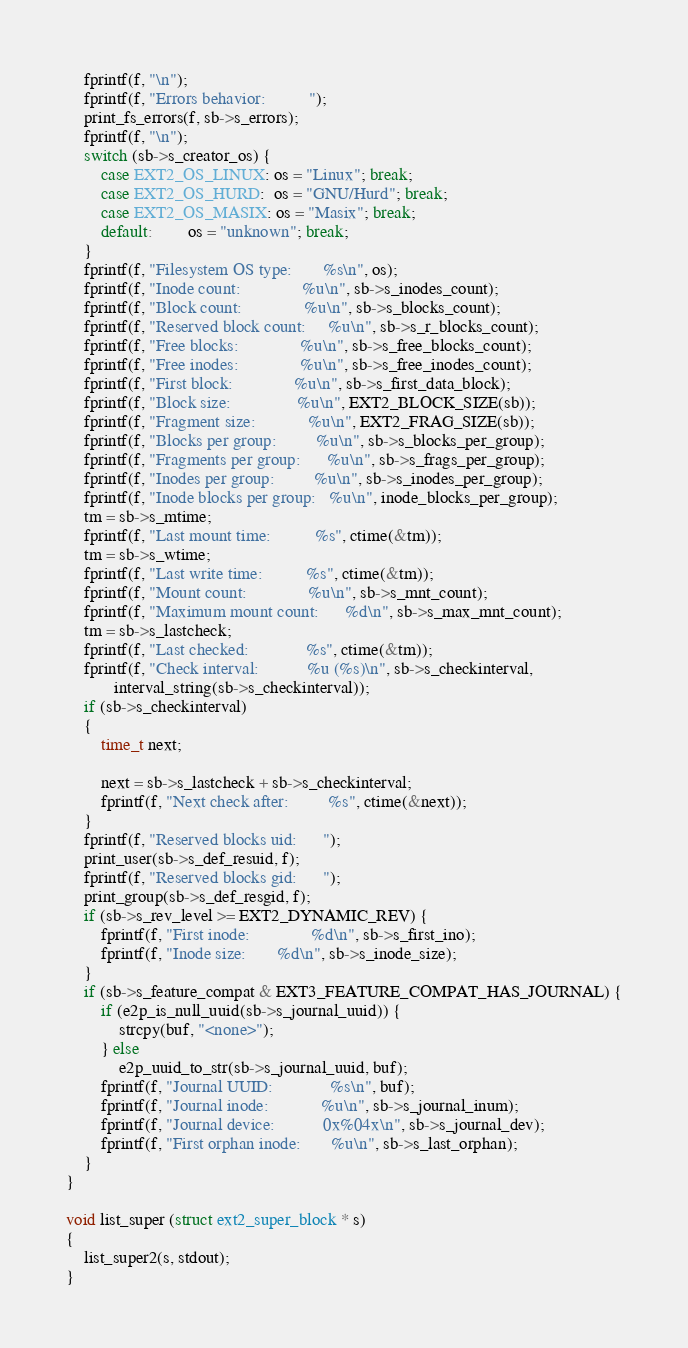<code> <loc_0><loc_0><loc_500><loc_500><_C_>	fprintf(f, "\n");
	fprintf(f, "Errors behavior:          ");
	print_fs_errors(f, sb->s_errors);
	fprintf(f, "\n");
	switch (sb->s_creator_os) {
	    case EXT2_OS_LINUX: os = "Linux"; break;
	    case EXT2_OS_HURD:  os = "GNU/Hurd"; break;
	    case EXT2_OS_MASIX: os = "Masix"; break;
	    default:		os = "unknown"; break;
	}
	fprintf(f, "Filesystem OS type:       %s\n", os);
	fprintf(f, "Inode count:              %u\n", sb->s_inodes_count);
	fprintf(f, "Block count:              %u\n", sb->s_blocks_count);
	fprintf(f, "Reserved block count:     %u\n", sb->s_r_blocks_count);
	fprintf(f, "Free blocks:              %u\n", sb->s_free_blocks_count);
	fprintf(f, "Free inodes:              %u\n", sb->s_free_inodes_count);
	fprintf(f, "First block:              %u\n", sb->s_first_data_block);
	fprintf(f, "Block size:               %u\n", EXT2_BLOCK_SIZE(sb));
	fprintf(f, "Fragment size:            %u\n", EXT2_FRAG_SIZE(sb));
	fprintf(f, "Blocks per group:         %u\n", sb->s_blocks_per_group);
	fprintf(f, "Fragments per group:      %u\n", sb->s_frags_per_group);
	fprintf(f, "Inodes per group:         %u\n", sb->s_inodes_per_group);
	fprintf(f, "Inode blocks per group:   %u\n", inode_blocks_per_group);
	tm = sb->s_mtime;
	fprintf(f, "Last mount time:          %s", ctime(&tm));
	tm = sb->s_wtime;
	fprintf(f, "Last write time:          %s", ctime(&tm));
	fprintf(f, "Mount count:              %u\n", sb->s_mnt_count);
	fprintf(f, "Maximum mount count:      %d\n", sb->s_max_mnt_count);
	tm = sb->s_lastcheck;
	fprintf(f, "Last checked:             %s", ctime(&tm));
	fprintf(f, "Check interval:           %u (%s)\n", sb->s_checkinterval,
	       interval_string(sb->s_checkinterval));
	if (sb->s_checkinterval)
	{
		time_t next;

		next = sb->s_lastcheck + sb->s_checkinterval;
		fprintf(f, "Next check after:         %s", ctime(&next));
	}
	fprintf(f, "Reserved blocks uid:      ");
	print_user(sb->s_def_resuid, f);
	fprintf(f, "Reserved blocks gid:      ");
	print_group(sb->s_def_resgid, f);
	if (sb->s_rev_level >= EXT2_DYNAMIC_REV) {
		fprintf(f, "First inode:              %d\n", sb->s_first_ino);
		fprintf(f, "Inode size:		  %d\n", sb->s_inode_size);
	}
	if (sb->s_feature_compat & EXT3_FEATURE_COMPAT_HAS_JOURNAL) {
		if (e2p_is_null_uuid(sb->s_journal_uuid)) {
			strcpy(buf, "<none>");
		} else
			e2p_uuid_to_str(sb->s_journal_uuid, buf);
		fprintf(f, "Journal UUID:             %s\n", buf);
		fprintf(f, "Journal inode:            %u\n", sb->s_journal_inum);
		fprintf(f, "Journal device:	          0x%04x\n", sb->s_journal_dev);
		fprintf(f, "First orphan inode:       %u\n", sb->s_last_orphan);
	}
}

void list_super (struct ext2_super_block * s)
{
	list_super2(s, stdout);
}

</code> 